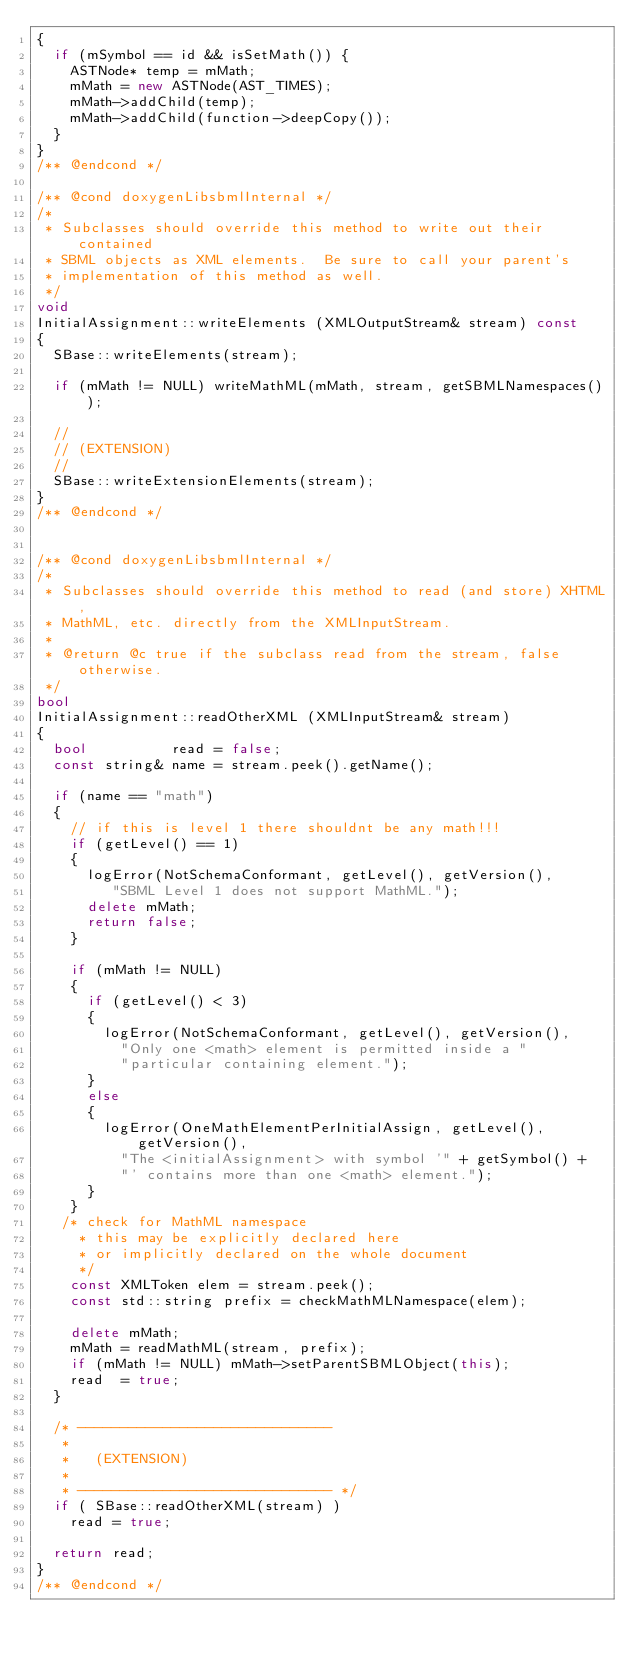<code> <loc_0><loc_0><loc_500><loc_500><_C++_>{
  if (mSymbol == id && isSetMath()) {
    ASTNode* temp = mMath;
    mMath = new ASTNode(AST_TIMES);
    mMath->addChild(temp);
    mMath->addChild(function->deepCopy());
  }
}
/** @endcond */

/** @cond doxygenLibsbmlInternal */
/*
 * Subclasses should override this method to write out their contained
 * SBML objects as XML elements.  Be sure to call your parent's
 * implementation of this method as well.
 */
void
InitialAssignment::writeElements (XMLOutputStream& stream) const
{
  SBase::writeElements(stream);

  if (mMath != NULL) writeMathML(mMath, stream, getSBMLNamespaces());

  //
  // (EXTENSION)
  //
  SBase::writeExtensionElements(stream);
}
/** @endcond */


/** @cond doxygenLibsbmlInternal */
/*
 * Subclasses should override this method to read (and store) XHTML,
 * MathML, etc. directly from the XMLInputStream.
 *
 * @return @c true if the subclass read from the stream, false otherwise.
 */
bool
InitialAssignment::readOtherXML (XMLInputStream& stream)
{
  bool          read = false;
  const string& name = stream.peek().getName();

  if (name == "math")
  {
    // if this is level 1 there shouldnt be any math!!!
    if (getLevel() == 1) 
    {
      logError(NotSchemaConformant, getLevel(), getVersion(),
         "SBML Level 1 does not support MathML.");
      delete mMath;
      return false;
    }

    if (mMath != NULL)
    {
      if (getLevel() < 3) 
      {
        logError(NotSchemaConformant, getLevel(), getVersion(),
          "Only one <math> element is permitted inside a "
          "particular containing element.");
      }
      else
      {
        logError(OneMathElementPerInitialAssign, getLevel(), getVersion(),
          "The <initialAssignment> with symbol '" + getSymbol() + 
          "' contains more than one <math> element.");
      }
    }
   /* check for MathML namespace 
     * this may be explicitly declared here
     * or implicitly declared on the whole document
     */
    const XMLToken elem = stream.peek();
    const std::string prefix = checkMathMLNamespace(elem);

    delete mMath;
    mMath = readMathML(stream, prefix);
    if (mMath != NULL) mMath->setParentSBMLObject(this);
    read  = true;
  }

  /* ------------------------------
   *
   *   (EXTENSION)
   *
   * ------------------------------ */
  if ( SBase::readOtherXML(stream) )
    read = true;

  return read;
}
/** @endcond */

</code> 